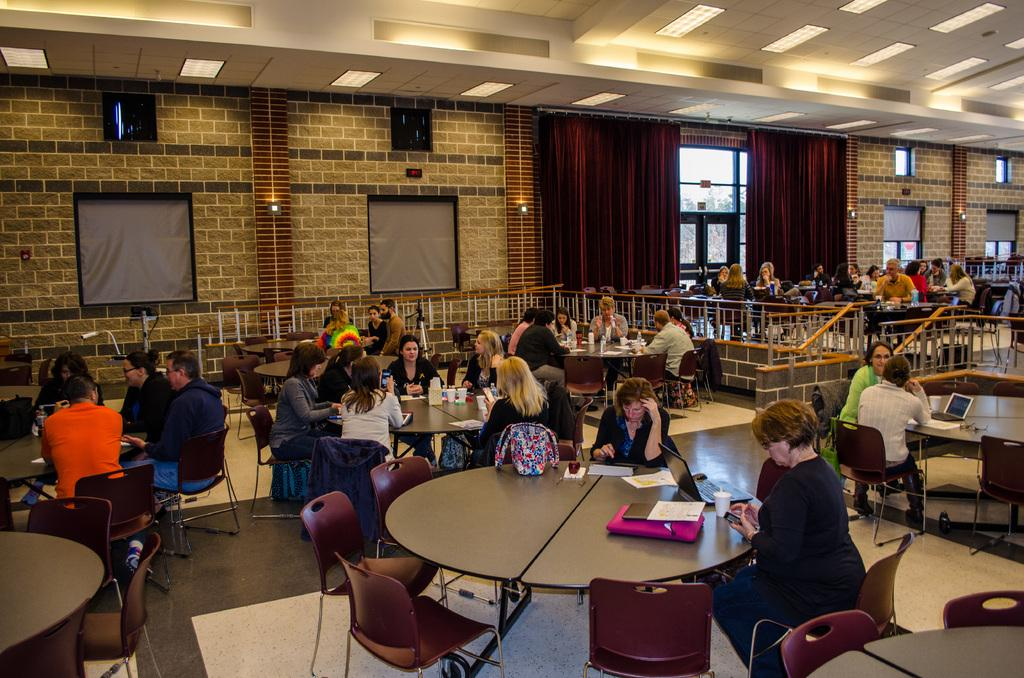What are the people in the image doing? The people in the image are sitting on chairs. What objects are present in the image that the people might be using? There are tables in the image that the people might be using. What type of window treatment can be seen in the image? There are two curtains in the image. What type of copper hydrant can be seen in the image? There is no copper hydrant present in the image. 